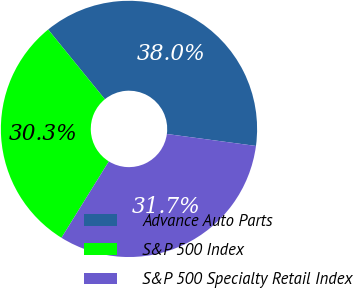Convert chart to OTSL. <chart><loc_0><loc_0><loc_500><loc_500><pie_chart><fcel>Advance Auto Parts<fcel>S&P 500 Index<fcel>S&P 500 Specialty Retail Index<nl><fcel>37.99%<fcel>30.29%<fcel>31.71%<nl></chart> 